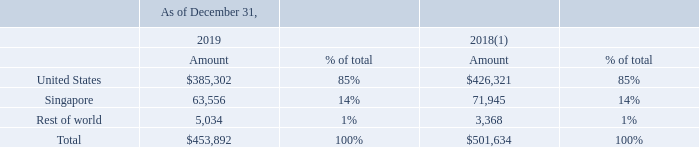The determination of which country a particular sale is allocated to is based on the destination of the product shipment. No other individual country accounted for more than 10% of net revenue during these periods. Although a large percentage of the Company’s products is shipped to Asia, and in particular, China, the Company believes that a significant number of the systems designed by customers and incorporating the Company’s semiconductor products are subsequently sold outside Asia to Europe, Middle East, and Africa, or EMEA markets and North American markets.
Long-lived assets, which consists of property and equipment, net, leased right-of-use assets, intangible assets, net, and goodwill, by geographic area are as follows (in thousands):
(1) Amounts do not include leased right-of-use assets in the prior period due to the adoption of ASC 842 under the modified retrospective method with a cumulative effect adjustment to accumulated deficit as of January 1, 2019.
What was the respective amount in 2019 and 2018 from Singapore?
Answer scale should be: thousand. 63,556, 71,945. What was the respective amount in 2019 and 2018 from United States?
Answer scale should be: thousand. $385,302, $426,321. What was the percentage of total from Singapore in 2019?
Answer scale should be: percent. 14. What was the change in the United States amount from 2018 to 2019?
Answer scale should be: thousand. 385,302 - 426,321
Answer: -41019. What was the average amount from Singapore in 2018 and 2019?
Answer scale should be: thousand. (63,556 + 71,945) / 2
Answer: 67750.5. What was the average total amount in 2018 and 2019?
Answer scale should be: thousand. (453,892 + 501,634) / 2
Answer: 477763. 